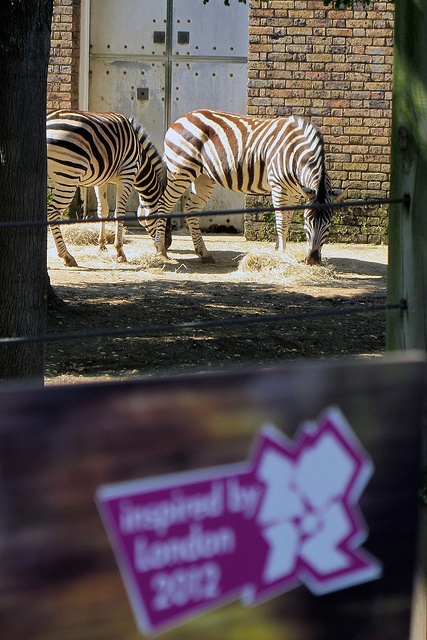Describe the objects in this image and their specific colors. I can see zebra in black, lightgray, tan, and gray tones and zebra in black, tan, and gray tones in this image. 